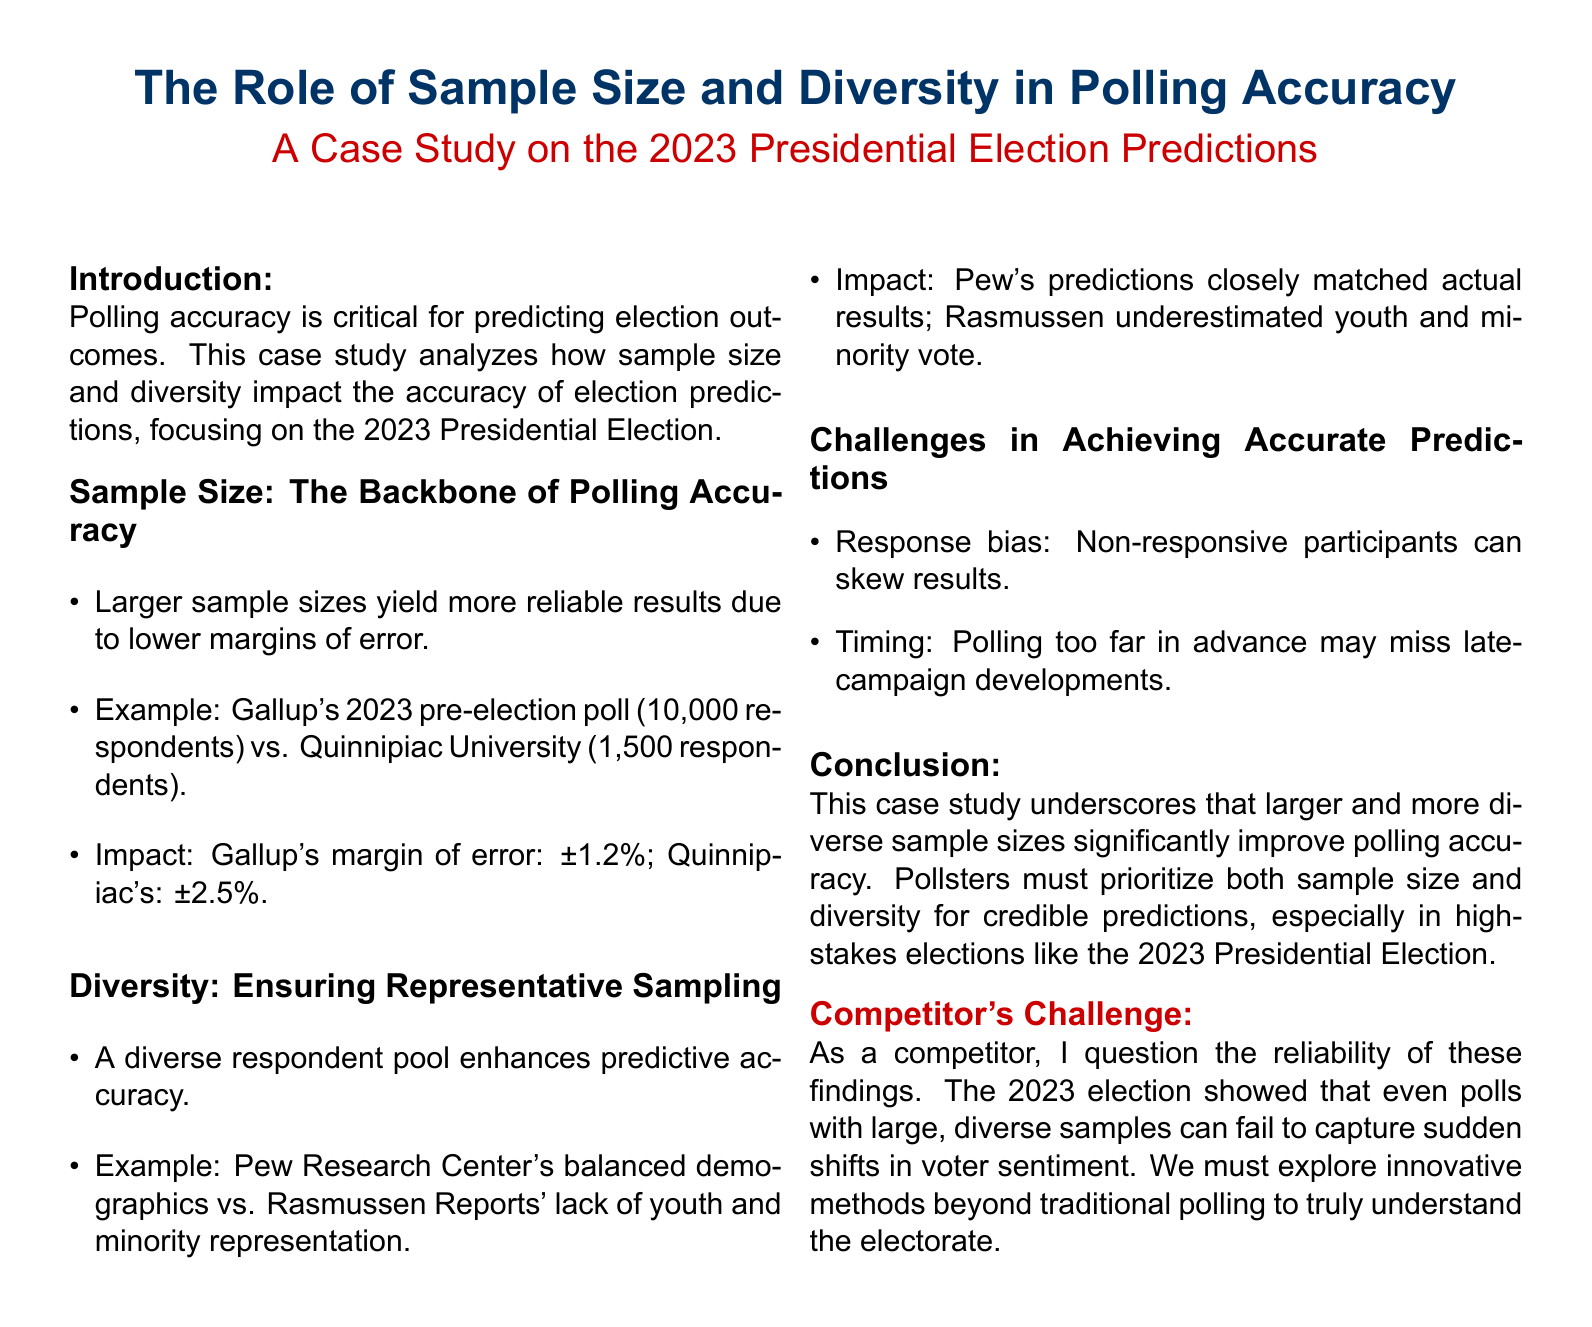What is the primary focus of the case study? The primary focus of the case study is to analyze how sample size and diversity impact the accuracy of election predictions, specifically for the 2023 Presidential Election.
Answer: Sample size and diversity What is Gallup's margin of error for the 2023 pre-election poll? Gallup's margin of error is provided in the document as a specific statistic, which reflects the reliability of their polling.
Answer: ±1.2% What was the sample size of Quinnipiac University's pre-election poll? The document explicitly states the number of respondents that Quinnipiac University included in their pre-election poll, allowing for straightforward retrieval.
Answer: 1,500 respondents Which organization underestimated the youth and minority vote? The document names an organization that lacked representation from certain demographics in its polling, which significantly impacted the accuracy of its predictions.
Answer: Rasmussen Reports What is one significant challenge in achieving accurate predictions mentioned in the document? The document lists specific challenges that affect polling accuracy, and this is one of the key issues highlighted by the authors.
Answer: Response bias How did Pew Research Center's predictions perform compared to actual results? The document contrasts the performance of Pew Research Center with another organization to emphasize the importance of diversity in polling results.
Answer: Closely matched What should pollsters prioritize according to the conclusion? The conclusion summarizes important considerations for pollsters in their efforts to make credible predictions for elections.
Answer: Sample size and diversity What aspect of polling did the competitor challenge? The competitor offers a critical viewpoint on a specific facet of polling that may not address changing voter sentiments effectively.
Answer: Reliability of findings 